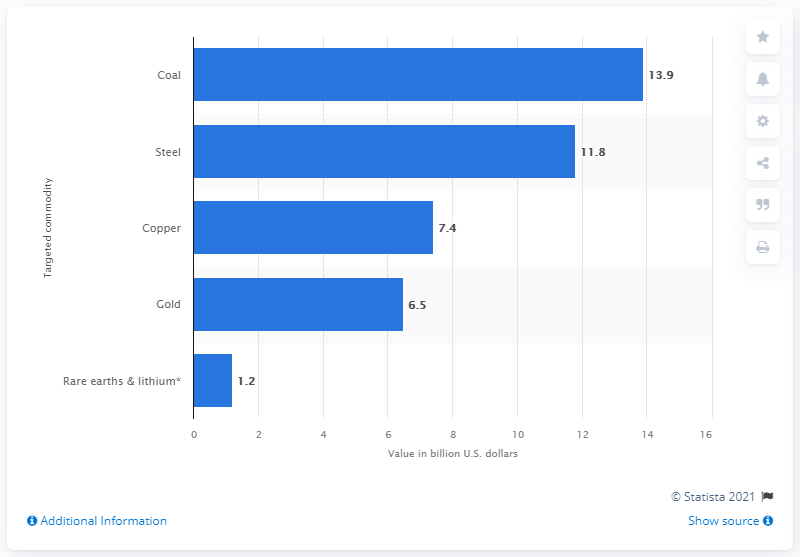Highlight a few significant elements in this photo. In 2018, the value of steel deals was 11.8 billion dollars. 